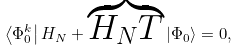<formula> <loc_0><loc_0><loc_500><loc_500>\left \langle \Phi _ { 0 } ^ { k } \right | H _ { N } + \overbrace { H _ { N } T } \left | \Phi _ { 0 } \right \rangle = 0 ,</formula> 